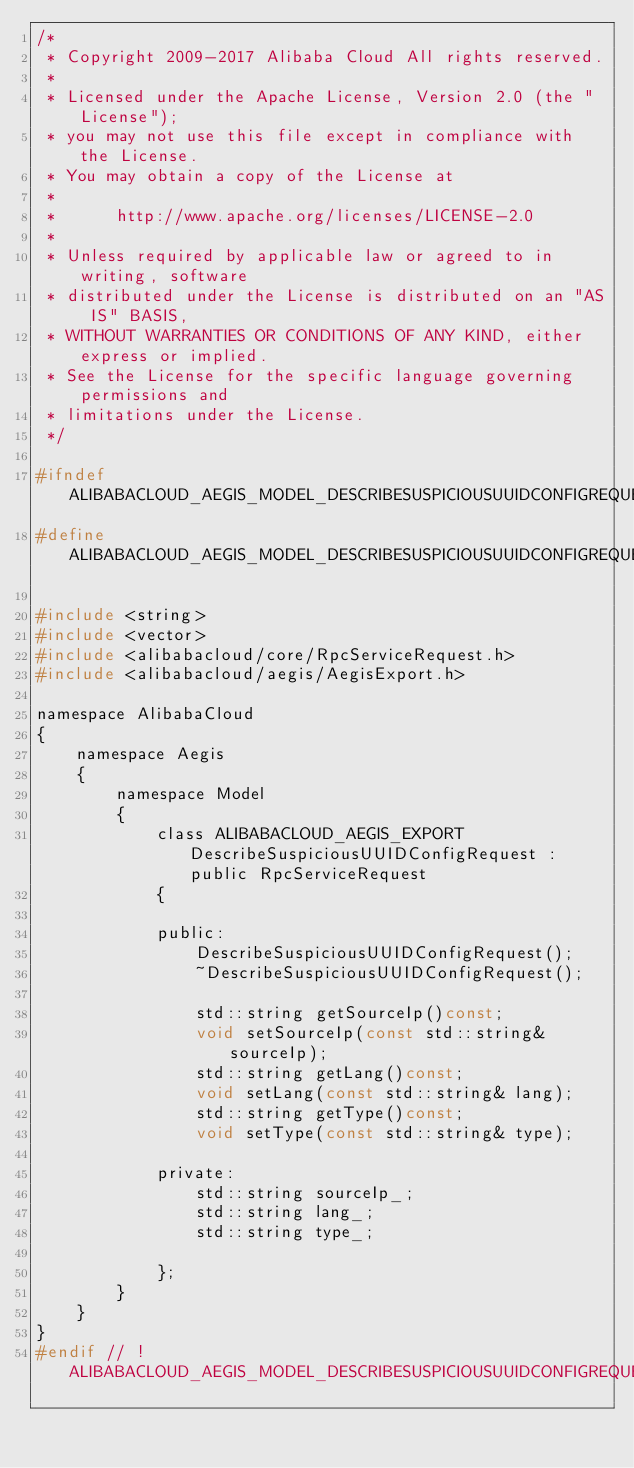Convert code to text. <code><loc_0><loc_0><loc_500><loc_500><_C_>/*
 * Copyright 2009-2017 Alibaba Cloud All rights reserved.
 * 
 * Licensed under the Apache License, Version 2.0 (the "License");
 * you may not use this file except in compliance with the License.
 * You may obtain a copy of the License at
 * 
 *      http://www.apache.org/licenses/LICENSE-2.0
 * 
 * Unless required by applicable law or agreed to in writing, software
 * distributed under the License is distributed on an "AS IS" BASIS,
 * WITHOUT WARRANTIES OR CONDITIONS OF ANY KIND, either express or implied.
 * See the License for the specific language governing permissions and
 * limitations under the License.
 */

#ifndef ALIBABACLOUD_AEGIS_MODEL_DESCRIBESUSPICIOUSUUIDCONFIGREQUEST_H_
#define ALIBABACLOUD_AEGIS_MODEL_DESCRIBESUSPICIOUSUUIDCONFIGREQUEST_H_

#include <string>
#include <vector>
#include <alibabacloud/core/RpcServiceRequest.h>
#include <alibabacloud/aegis/AegisExport.h>

namespace AlibabaCloud
{
	namespace Aegis
	{
		namespace Model
		{
			class ALIBABACLOUD_AEGIS_EXPORT DescribeSuspiciousUUIDConfigRequest : public RpcServiceRequest
			{

			public:
				DescribeSuspiciousUUIDConfigRequest();
				~DescribeSuspiciousUUIDConfigRequest();

				std::string getSourceIp()const;
				void setSourceIp(const std::string& sourceIp);
				std::string getLang()const;
				void setLang(const std::string& lang);
				std::string getType()const;
				void setType(const std::string& type);

            private:
				std::string sourceIp_;
				std::string lang_;
				std::string type_;

			};
		}
	}
}
#endif // !ALIBABACLOUD_AEGIS_MODEL_DESCRIBESUSPICIOUSUUIDCONFIGREQUEST_H_</code> 